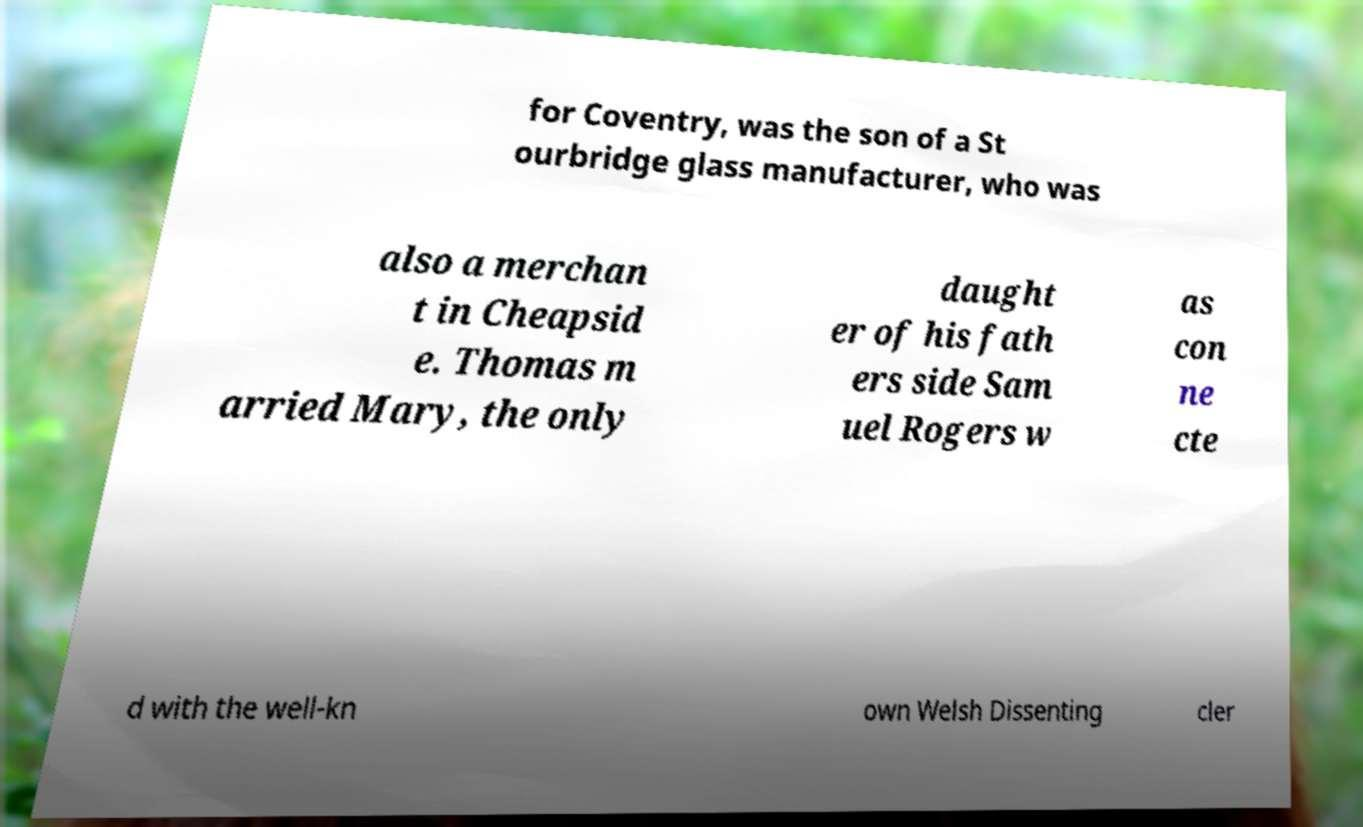I need the written content from this picture converted into text. Can you do that? for Coventry, was the son of a St ourbridge glass manufacturer, who was also a merchan t in Cheapsid e. Thomas m arried Mary, the only daught er of his fath ers side Sam uel Rogers w as con ne cte d with the well-kn own Welsh Dissenting cler 